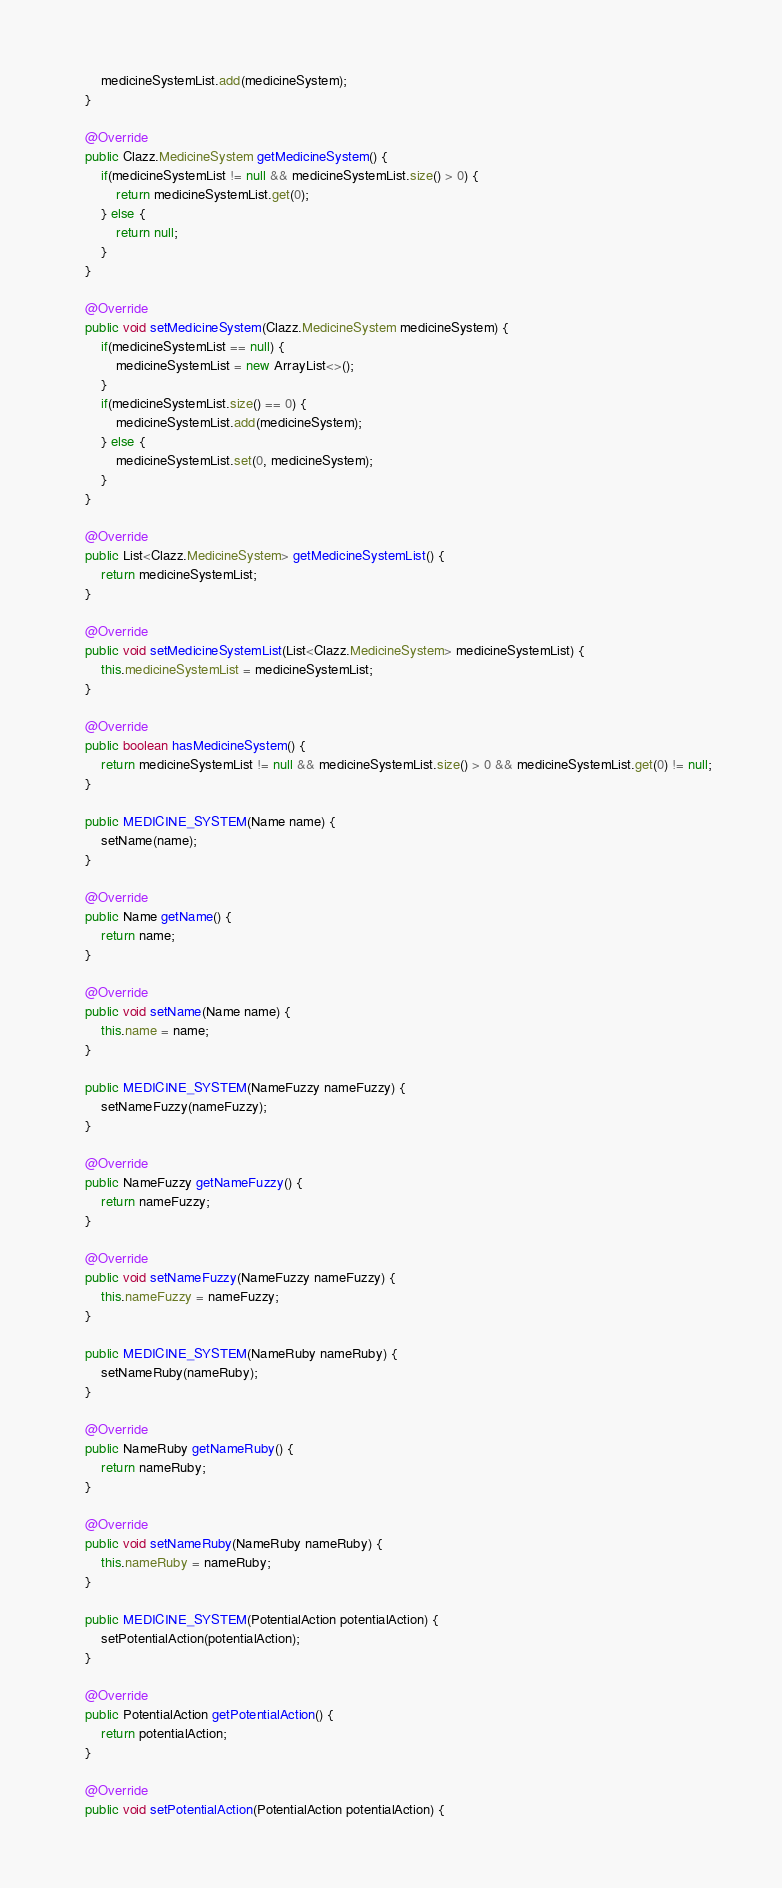Convert code to text. <code><loc_0><loc_0><loc_500><loc_500><_Java_>		medicineSystemList.add(medicineSystem);
	}

	@Override
	public Clazz.MedicineSystem getMedicineSystem() {
		if(medicineSystemList != null && medicineSystemList.size() > 0) {
			return medicineSystemList.get(0);
		} else {
			return null;
		}
	}

	@Override
	public void setMedicineSystem(Clazz.MedicineSystem medicineSystem) {
		if(medicineSystemList == null) {
			medicineSystemList = new ArrayList<>();
		}
		if(medicineSystemList.size() == 0) {
			medicineSystemList.add(medicineSystem);
		} else {
			medicineSystemList.set(0, medicineSystem);
		}
	}

	@Override
	public List<Clazz.MedicineSystem> getMedicineSystemList() {
		return medicineSystemList;
	}

	@Override
	public void setMedicineSystemList(List<Clazz.MedicineSystem> medicineSystemList) {
		this.medicineSystemList = medicineSystemList;
	}

	@Override
	public boolean hasMedicineSystem() {
		return medicineSystemList != null && medicineSystemList.size() > 0 && medicineSystemList.get(0) != null;
	}

	public MEDICINE_SYSTEM(Name name) {
		setName(name);
	}

	@Override
	public Name getName() {
		return name;
	}

	@Override
	public void setName(Name name) {
		this.name = name;
	}

	public MEDICINE_SYSTEM(NameFuzzy nameFuzzy) {
		setNameFuzzy(nameFuzzy);
	}

	@Override
	public NameFuzzy getNameFuzzy() {
		return nameFuzzy;
	}

	@Override
	public void setNameFuzzy(NameFuzzy nameFuzzy) {
		this.nameFuzzy = nameFuzzy;
	}

	public MEDICINE_SYSTEM(NameRuby nameRuby) {
		setNameRuby(nameRuby);
	}

	@Override
	public NameRuby getNameRuby() {
		return nameRuby;
	}

	@Override
	public void setNameRuby(NameRuby nameRuby) {
		this.nameRuby = nameRuby;
	}

	public MEDICINE_SYSTEM(PotentialAction potentialAction) {
		setPotentialAction(potentialAction);
	}

	@Override
	public PotentialAction getPotentialAction() {
		return potentialAction;
	}

	@Override
	public void setPotentialAction(PotentialAction potentialAction) {</code> 